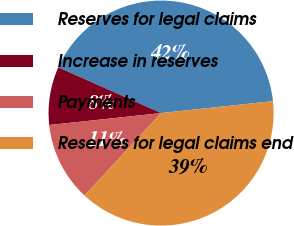Convert chart. <chart><loc_0><loc_0><loc_500><loc_500><pie_chart><fcel>Reserves for legal claims<fcel>Increase in reserves<fcel>Payments<fcel>Reserves for legal claims end<nl><fcel>41.65%<fcel>8.35%<fcel>11.4%<fcel>38.6%<nl></chart> 